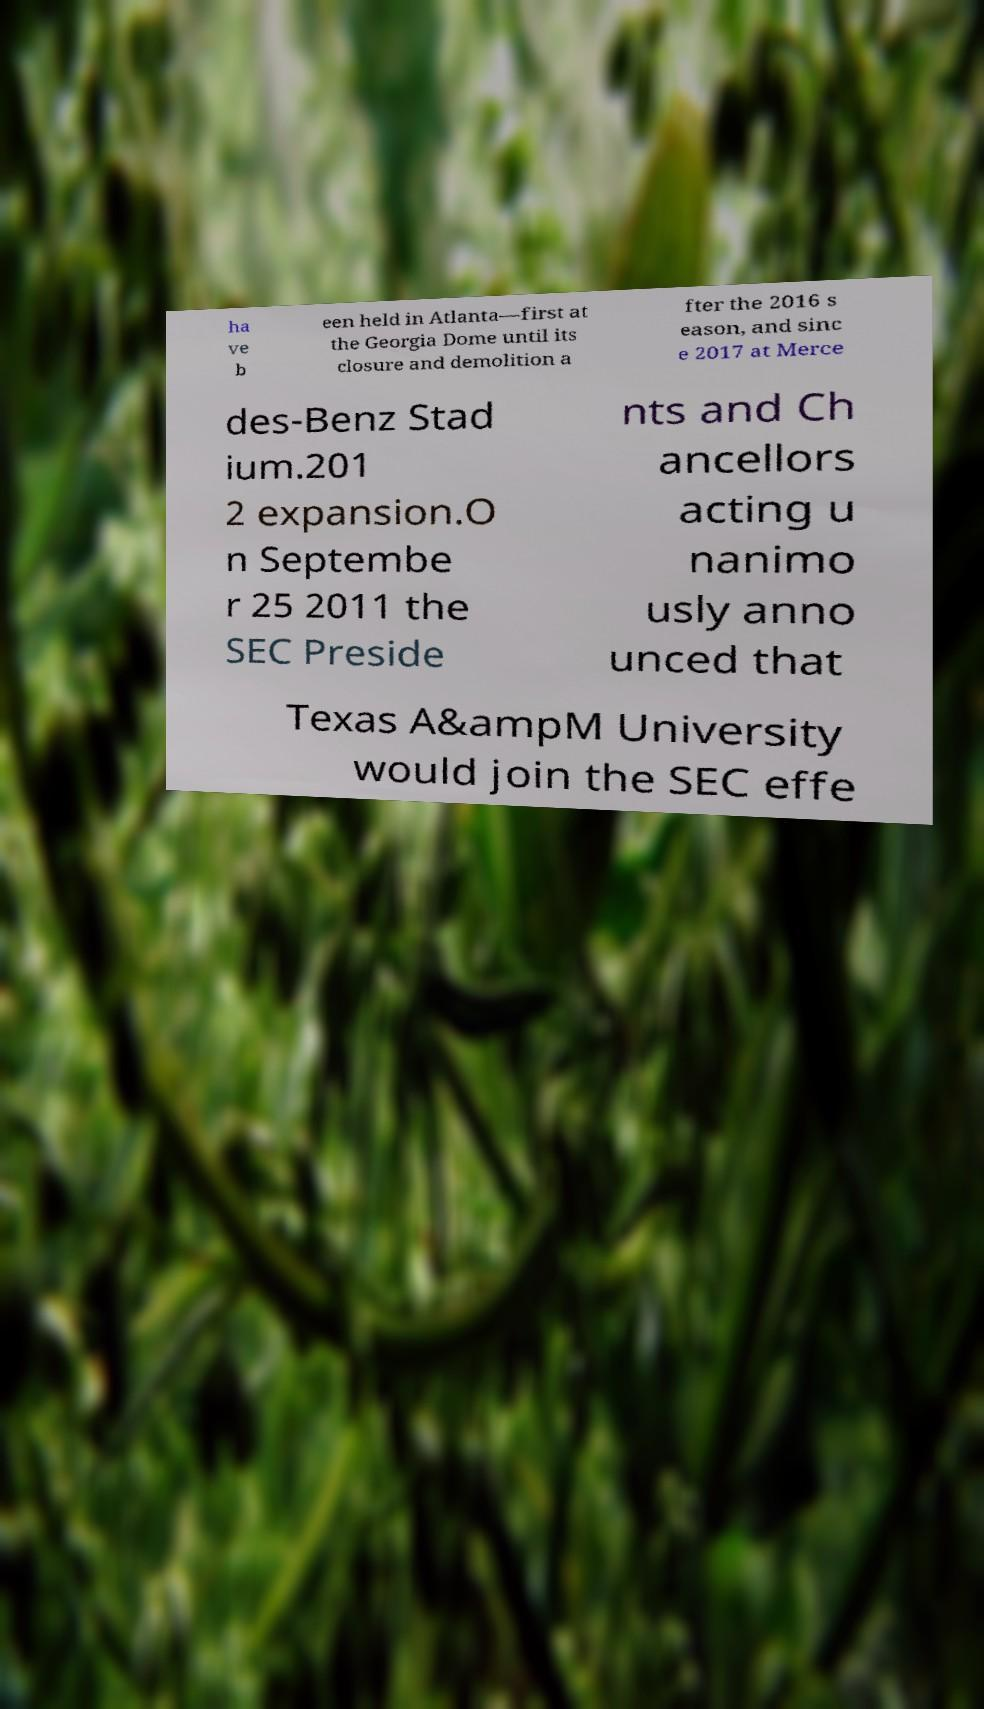For documentation purposes, I need the text within this image transcribed. Could you provide that? ha ve b een held in Atlanta—first at the Georgia Dome until its closure and demolition a fter the 2016 s eason, and sinc e 2017 at Merce des-Benz Stad ium.201 2 expansion.O n Septembe r 25 2011 the SEC Preside nts and Ch ancellors acting u nanimo usly anno unced that Texas A&ampM University would join the SEC effe 